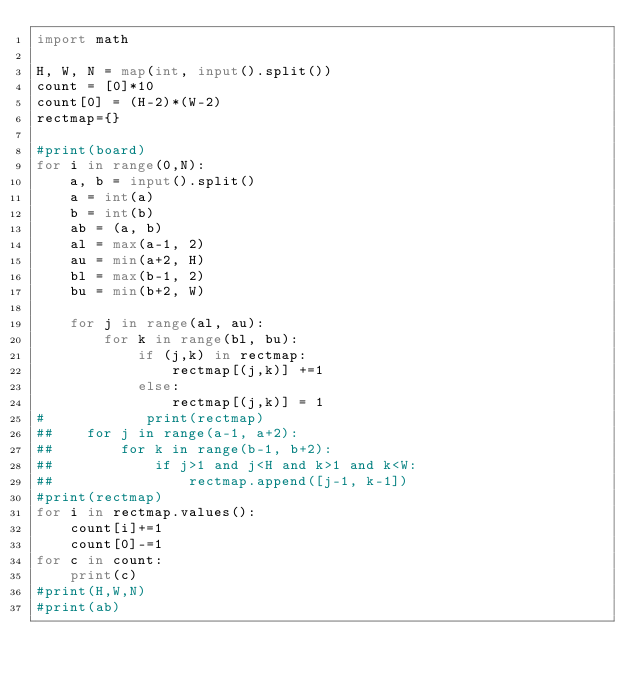<code> <loc_0><loc_0><loc_500><loc_500><_Python_>import math

H, W, N = map(int, input().split())
count = [0]*10
count[0] = (H-2)*(W-2)
rectmap={}

#print(board)
for i in range(0,N):
    a, b = input().split()
    a = int(a)
    b = int(b)
    ab = (a, b)
    al = max(a-1, 2)
    au = min(a+2, H)
    bl = max(b-1, 2)
    bu = min(b+2, W)

    for j in range(al, au):
        for k in range(bl, bu):
            if (j,k) in rectmap:
                rectmap[(j,k)] +=1
            else:
                rectmap[(j,k)] = 1
#            print(rectmap)
##    for j in range(a-1, a+2):
##        for k in range(b-1, b+2):
##            if j>1 and j<H and k>1 and k<W:
##                rectmap.append([j-1, k-1])
#print(rectmap)
for i in rectmap.values():
    count[i]+=1
    count[0]-=1
for c in count:
    print(c)
#print(H,W,N)
#print(ab)
</code> 